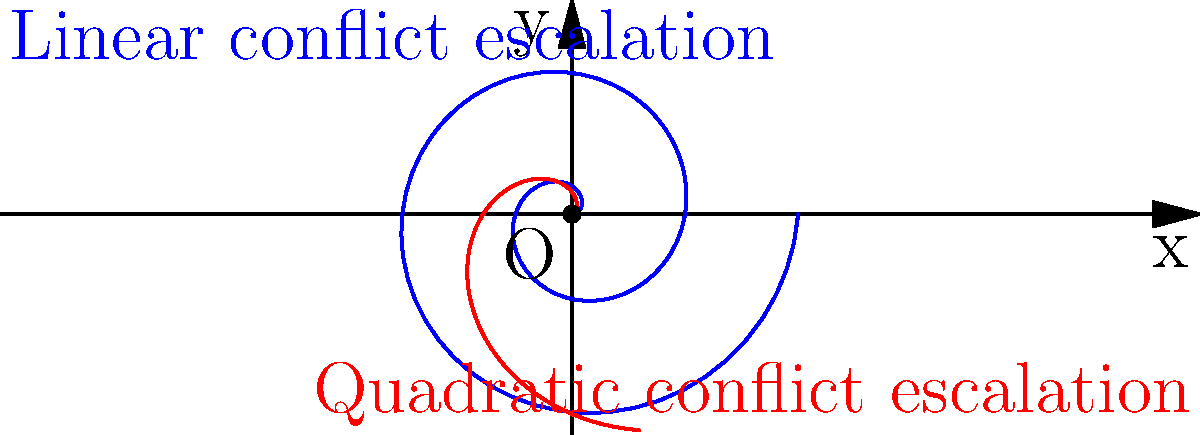In the polar coordinate graph above, two spiral patterns represent different conflict escalation scenarios in a region. The blue spiral follows a linear pattern $r = 0.2\theta$, while the red spiral follows a quadratic pattern $r = 0.1\theta^2$. If $\theta$ represents time and $r$ represents conflict intensity, what does the difference in these patterns suggest about the nature of conflict escalation in each scenario? To interpret the spiral patterns and their implications for conflict escalation, let's analyze the given information step-by-step:

1. Blue spiral (linear pattern): $r = 0.2\theta$
   - This equation represents a linear relationship between $r$ (conflict intensity) and $\theta$ (time).
   - As time increases, the conflict intensity increases at a constant rate.

2. Red spiral (quadratic pattern): $r = 0.1\theta^2$
   - This equation represents a quadratic relationship between $r$ and $\theta$.
   - As time increases, the conflict intensity increases at an accelerating rate.

3. Comparing the patterns:
   - Initially, the blue spiral (linear) grows faster than the red spiral (quadratic).
   - However, as $\theta$ increases, the red spiral eventually overtakes the blue spiral.
   - This crossover point can be found by solving the equation $0.2\theta = 0.1\theta^2$, which occurs at $\theta = 2$.

4. Interpretation for conflict scenarios:
   - The linear pattern (blue) suggests a steady, predictable escalation of conflict over time.
   - The quadratic pattern (red) implies a conflict that starts slowly but accelerates rapidly as time progresses.

5. Implications for conflict analysis:
   - Linear escalation may be easier to predict and potentially manage.
   - Quadratic escalation indicates a more volatile situation that could quickly spiral out of control.
   - Understanding these patterns can help in developing appropriate intervention strategies and resource allocation for conflict management.
Answer: The linear pattern suggests steady conflict escalation, while the quadratic pattern indicates accelerating escalation that becomes more intense over time, implying a potentially more volatile and unpredictable conflict scenario. 